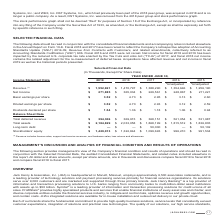From Jack Henry Associates's financial document, Which financial years' information is shown in the table? The document contains multiple relevant values: 2015, 2016, 2017, 2018, 2019. From the document: "Income Statement Data 2019 2018 2017 2016 2015 Income Statement Data 2019 2018 2017 2016 2015 Income Statement Data 2019 2018 2017 2016 2015 Income St..." Also, What is the revenue for all 5 fiscal years, in chronological order? The document contains multiple relevant values: $1,256,190, $1,354,646, $1,388,290, $1,470,797, $1,552,691 (in thousands). From the document: "$ 1,552,691 $ 1,470,797 $ 1,388,290 $ 1,354,646 $ 1,256,190 Revenue (1) $ 1,552,691 $ 1,470,797 $ 1,388,290 $ 1,354,646 $ 1,256,190 Revenue (1) $ 1,55..." Also, What is the net income for all 5 fiscal years, in chronological order? The document contains multiple relevant values: $211,221, $248,867, $229,561, $365,034, $271,885 (in thousands). From the document: "Income $ 271,885 $ 365,034 $ 229,561 $ 248,867 $ 211,221 Net Income $ 271,885 $ 365,034 $ 229,561 $ 248,867 $ 211,221 Net Income $ 271,885 $ 365,034 $..." Also, can you calculate: What is the average revenue for 2018 and 2019? To answer this question, I need to perform calculations using the financial data. The calculation is: ($1,552,691+$1,470,797)/2, which equals 1511744 (in thousands). This is based on the information: "Revenue (1) $ 1,552,691 $ 1,470,797 $ 1,388,290 $ 1,354,646 $ 1,256,190 Revenue (1) $ 1,552,691 $ 1,470,797 $ 1,388,290 $ 1,354,646 $ 1,256,190..." The key data points involved are: 1,470,797, 1,552,691. Also, can you calculate: What is the average revenue for 2017 and 2018? To answer this question, I need to perform calculations using the financial data. The calculation is: ($1,470,797+$1,388,290)/2, which equals 1429543.5 (in thousands). This is based on the information: "Revenue (1) $ 1,552,691 $ 1,470,797 $ 1,388,290 $ 1,354,646 $ 1,256,190 Revenue (1) $ 1,552,691 $ 1,470,797 $ 1,388,290 $ 1,354,646 $ 1,256,190..." The key data points involved are: 1,388,290, 1,470,797. Also, can you calculate: What is the change in the average revenue between 2017-2018 and 2018-2019? To answer this question, I need to perform calculations using the financial data. The calculation is: [($1,552,691+$1,470,797)/2] - [($1,470,797+$1,388,290)/2], which equals 82200.5 (in thousands). This is based on the information: "Revenue (1) $ 1,552,691 $ 1,470,797 $ 1,388,290 $ 1,354,646 $ 1,256,190 Revenue (1) $ 1,552,691 $ 1,470,797 $ 1,388,290 $ 1,354,646 $ 1,256,190 Revenue (1) $ 1,552,691 $ 1,470,797 $ 1,388,290 $ 1,354,..." The key data points involved are: 1,388,290, 1,470,797, 1,552,691. 